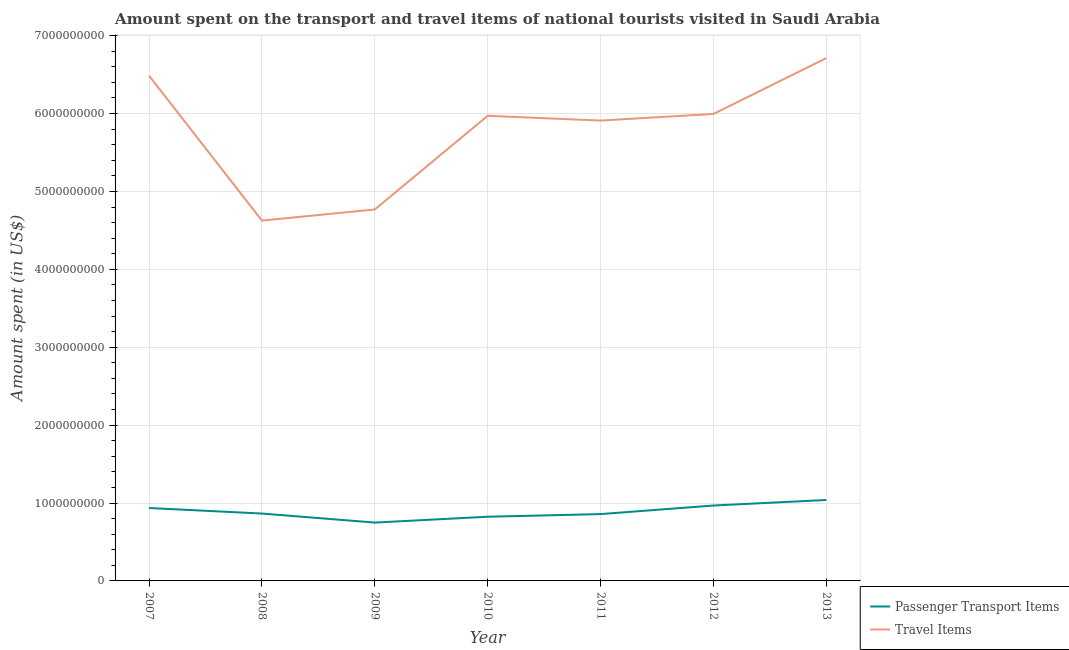How many different coloured lines are there?
Your answer should be very brief. 2. Does the line corresponding to amount spent on passenger transport items intersect with the line corresponding to amount spent in travel items?
Your response must be concise. No. Is the number of lines equal to the number of legend labels?
Your answer should be very brief. Yes. What is the amount spent in travel items in 2009?
Your answer should be very brief. 4.77e+09. Across all years, what is the maximum amount spent on passenger transport items?
Ensure brevity in your answer.  1.04e+09. Across all years, what is the minimum amount spent in travel items?
Your answer should be compact. 4.63e+09. What is the total amount spent in travel items in the graph?
Make the answer very short. 4.05e+1. What is the difference between the amount spent on passenger transport items in 2007 and that in 2010?
Your response must be concise. 1.12e+08. What is the difference between the amount spent on passenger transport items in 2013 and the amount spent in travel items in 2008?
Provide a short and direct response. -3.59e+09. What is the average amount spent on passenger transport items per year?
Offer a terse response. 8.91e+08. In the year 2008, what is the difference between the amount spent in travel items and amount spent on passenger transport items?
Offer a very short reply. 3.76e+09. In how many years, is the amount spent on passenger transport items greater than 400000000 US$?
Provide a succinct answer. 7. What is the ratio of the amount spent in travel items in 2011 to that in 2013?
Provide a succinct answer. 0.88. What is the difference between the highest and the second highest amount spent on passenger transport items?
Provide a succinct answer. 7.10e+07. What is the difference between the highest and the lowest amount spent in travel items?
Your answer should be compact. 2.09e+09. In how many years, is the amount spent on passenger transport items greater than the average amount spent on passenger transport items taken over all years?
Provide a succinct answer. 3. Is the sum of the amount spent in travel items in 2007 and 2012 greater than the maximum amount spent on passenger transport items across all years?
Keep it short and to the point. Yes. How many lines are there?
Provide a succinct answer. 2. Are the values on the major ticks of Y-axis written in scientific E-notation?
Offer a terse response. No. Does the graph contain grids?
Give a very brief answer. Yes. Where does the legend appear in the graph?
Keep it short and to the point. Bottom right. How many legend labels are there?
Your response must be concise. 2. How are the legend labels stacked?
Make the answer very short. Vertical. What is the title of the graph?
Keep it short and to the point. Amount spent on the transport and travel items of national tourists visited in Saudi Arabia. Does "Female" appear as one of the legend labels in the graph?
Provide a succinct answer. No. What is the label or title of the Y-axis?
Offer a terse response. Amount spent (in US$). What is the Amount spent (in US$) in Passenger Transport Items in 2007?
Give a very brief answer. 9.36e+08. What is the Amount spent (in US$) in Travel Items in 2007?
Ensure brevity in your answer.  6.49e+09. What is the Amount spent (in US$) of Passenger Transport Items in 2008?
Ensure brevity in your answer.  8.65e+08. What is the Amount spent (in US$) of Travel Items in 2008?
Ensure brevity in your answer.  4.63e+09. What is the Amount spent (in US$) in Passenger Transport Items in 2009?
Provide a short and direct response. 7.49e+08. What is the Amount spent (in US$) of Travel Items in 2009?
Ensure brevity in your answer.  4.77e+09. What is the Amount spent (in US$) of Passenger Transport Items in 2010?
Offer a terse response. 8.24e+08. What is the Amount spent (in US$) of Travel Items in 2010?
Keep it short and to the point. 5.97e+09. What is the Amount spent (in US$) in Passenger Transport Items in 2011?
Offer a terse response. 8.58e+08. What is the Amount spent (in US$) of Travel Items in 2011?
Keep it short and to the point. 5.91e+09. What is the Amount spent (in US$) in Passenger Transport Items in 2012?
Your answer should be very brief. 9.68e+08. What is the Amount spent (in US$) in Travel Items in 2012?
Your answer should be compact. 6.00e+09. What is the Amount spent (in US$) of Passenger Transport Items in 2013?
Your answer should be compact. 1.04e+09. What is the Amount spent (in US$) in Travel Items in 2013?
Make the answer very short. 6.71e+09. Across all years, what is the maximum Amount spent (in US$) in Passenger Transport Items?
Offer a very short reply. 1.04e+09. Across all years, what is the maximum Amount spent (in US$) of Travel Items?
Keep it short and to the point. 6.71e+09. Across all years, what is the minimum Amount spent (in US$) of Passenger Transport Items?
Your answer should be compact. 7.49e+08. Across all years, what is the minimum Amount spent (in US$) in Travel Items?
Offer a terse response. 4.63e+09. What is the total Amount spent (in US$) in Passenger Transport Items in the graph?
Offer a terse response. 6.24e+09. What is the total Amount spent (in US$) in Travel Items in the graph?
Provide a short and direct response. 4.05e+1. What is the difference between the Amount spent (in US$) of Passenger Transport Items in 2007 and that in 2008?
Your response must be concise. 7.10e+07. What is the difference between the Amount spent (in US$) of Travel Items in 2007 and that in 2008?
Your answer should be very brief. 1.86e+09. What is the difference between the Amount spent (in US$) of Passenger Transport Items in 2007 and that in 2009?
Give a very brief answer. 1.87e+08. What is the difference between the Amount spent (in US$) of Travel Items in 2007 and that in 2009?
Make the answer very short. 1.72e+09. What is the difference between the Amount spent (in US$) of Passenger Transport Items in 2007 and that in 2010?
Your answer should be very brief. 1.12e+08. What is the difference between the Amount spent (in US$) in Travel Items in 2007 and that in 2010?
Offer a very short reply. 5.15e+08. What is the difference between the Amount spent (in US$) of Passenger Transport Items in 2007 and that in 2011?
Provide a short and direct response. 7.80e+07. What is the difference between the Amount spent (in US$) in Travel Items in 2007 and that in 2011?
Offer a very short reply. 5.76e+08. What is the difference between the Amount spent (in US$) of Passenger Transport Items in 2007 and that in 2012?
Ensure brevity in your answer.  -3.20e+07. What is the difference between the Amount spent (in US$) in Travel Items in 2007 and that in 2012?
Ensure brevity in your answer.  4.91e+08. What is the difference between the Amount spent (in US$) of Passenger Transport Items in 2007 and that in 2013?
Your answer should be very brief. -1.03e+08. What is the difference between the Amount spent (in US$) in Travel Items in 2007 and that in 2013?
Your response must be concise. -2.26e+08. What is the difference between the Amount spent (in US$) in Passenger Transport Items in 2008 and that in 2009?
Ensure brevity in your answer.  1.16e+08. What is the difference between the Amount spent (in US$) in Travel Items in 2008 and that in 2009?
Make the answer very short. -1.43e+08. What is the difference between the Amount spent (in US$) in Passenger Transport Items in 2008 and that in 2010?
Make the answer very short. 4.10e+07. What is the difference between the Amount spent (in US$) in Travel Items in 2008 and that in 2010?
Your response must be concise. -1.34e+09. What is the difference between the Amount spent (in US$) of Travel Items in 2008 and that in 2011?
Provide a short and direct response. -1.28e+09. What is the difference between the Amount spent (in US$) in Passenger Transport Items in 2008 and that in 2012?
Offer a very short reply. -1.03e+08. What is the difference between the Amount spent (in US$) of Travel Items in 2008 and that in 2012?
Your answer should be compact. -1.37e+09. What is the difference between the Amount spent (in US$) in Passenger Transport Items in 2008 and that in 2013?
Offer a terse response. -1.74e+08. What is the difference between the Amount spent (in US$) in Travel Items in 2008 and that in 2013?
Give a very brief answer. -2.09e+09. What is the difference between the Amount spent (in US$) of Passenger Transport Items in 2009 and that in 2010?
Offer a terse response. -7.50e+07. What is the difference between the Amount spent (in US$) in Travel Items in 2009 and that in 2010?
Offer a terse response. -1.20e+09. What is the difference between the Amount spent (in US$) of Passenger Transport Items in 2009 and that in 2011?
Provide a succinct answer. -1.09e+08. What is the difference between the Amount spent (in US$) of Travel Items in 2009 and that in 2011?
Your answer should be compact. -1.14e+09. What is the difference between the Amount spent (in US$) in Passenger Transport Items in 2009 and that in 2012?
Make the answer very short. -2.19e+08. What is the difference between the Amount spent (in US$) in Travel Items in 2009 and that in 2012?
Give a very brief answer. -1.23e+09. What is the difference between the Amount spent (in US$) of Passenger Transport Items in 2009 and that in 2013?
Ensure brevity in your answer.  -2.90e+08. What is the difference between the Amount spent (in US$) in Travel Items in 2009 and that in 2013?
Provide a short and direct response. -1.94e+09. What is the difference between the Amount spent (in US$) in Passenger Transport Items in 2010 and that in 2011?
Offer a terse response. -3.40e+07. What is the difference between the Amount spent (in US$) in Travel Items in 2010 and that in 2011?
Make the answer very short. 6.10e+07. What is the difference between the Amount spent (in US$) in Passenger Transport Items in 2010 and that in 2012?
Offer a very short reply. -1.44e+08. What is the difference between the Amount spent (in US$) of Travel Items in 2010 and that in 2012?
Your response must be concise. -2.40e+07. What is the difference between the Amount spent (in US$) of Passenger Transport Items in 2010 and that in 2013?
Offer a terse response. -2.15e+08. What is the difference between the Amount spent (in US$) of Travel Items in 2010 and that in 2013?
Make the answer very short. -7.41e+08. What is the difference between the Amount spent (in US$) in Passenger Transport Items in 2011 and that in 2012?
Keep it short and to the point. -1.10e+08. What is the difference between the Amount spent (in US$) in Travel Items in 2011 and that in 2012?
Your answer should be compact. -8.50e+07. What is the difference between the Amount spent (in US$) in Passenger Transport Items in 2011 and that in 2013?
Provide a succinct answer. -1.81e+08. What is the difference between the Amount spent (in US$) of Travel Items in 2011 and that in 2013?
Your answer should be very brief. -8.02e+08. What is the difference between the Amount spent (in US$) of Passenger Transport Items in 2012 and that in 2013?
Your answer should be compact. -7.10e+07. What is the difference between the Amount spent (in US$) of Travel Items in 2012 and that in 2013?
Make the answer very short. -7.17e+08. What is the difference between the Amount spent (in US$) of Passenger Transport Items in 2007 and the Amount spent (in US$) of Travel Items in 2008?
Provide a succinct answer. -3.69e+09. What is the difference between the Amount spent (in US$) of Passenger Transport Items in 2007 and the Amount spent (in US$) of Travel Items in 2009?
Ensure brevity in your answer.  -3.83e+09. What is the difference between the Amount spent (in US$) of Passenger Transport Items in 2007 and the Amount spent (in US$) of Travel Items in 2010?
Your response must be concise. -5.04e+09. What is the difference between the Amount spent (in US$) of Passenger Transport Items in 2007 and the Amount spent (in US$) of Travel Items in 2011?
Provide a short and direct response. -4.97e+09. What is the difference between the Amount spent (in US$) of Passenger Transport Items in 2007 and the Amount spent (in US$) of Travel Items in 2012?
Provide a short and direct response. -5.06e+09. What is the difference between the Amount spent (in US$) in Passenger Transport Items in 2007 and the Amount spent (in US$) in Travel Items in 2013?
Make the answer very short. -5.78e+09. What is the difference between the Amount spent (in US$) in Passenger Transport Items in 2008 and the Amount spent (in US$) in Travel Items in 2009?
Make the answer very short. -3.90e+09. What is the difference between the Amount spent (in US$) in Passenger Transport Items in 2008 and the Amount spent (in US$) in Travel Items in 2010?
Keep it short and to the point. -5.11e+09. What is the difference between the Amount spent (in US$) of Passenger Transport Items in 2008 and the Amount spent (in US$) of Travel Items in 2011?
Provide a succinct answer. -5.04e+09. What is the difference between the Amount spent (in US$) of Passenger Transport Items in 2008 and the Amount spent (in US$) of Travel Items in 2012?
Your answer should be very brief. -5.13e+09. What is the difference between the Amount spent (in US$) in Passenger Transport Items in 2008 and the Amount spent (in US$) in Travel Items in 2013?
Give a very brief answer. -5.85e+09. What is the difference between the Amount spent (in US$) of Passenger Transport Items in 2009 and the Amount spent (in US$) of Travel Items in 2010?
Make the answer very short. -5.22e+09. What is the difference between the Amount spent (in US$) of Passenger Transport Items in 2009 and the Amount spent (in US$) of Travel Items in 2011?
Your response must be concise. -5.16e+09. What is the difference between the Amount spent (in US$) in Passenger Transport Items in 2009 and the Amount spent (in US$) in Travel Items in 2012?
Your answer should be compact. -5.25e+09. What is the difference between the Amount spent (in US$) of Passenger Transport Items in 2009 and the Amount spent (in US$) of Travel Items in 2013?
Make the answer very short. -5.96e+09. What is the difference between the Amount spent (in US$) in Passenger Transport Items in 2010 and the Amount spent (in US$) in Travel Items in 2011?
Offer a very short reply. -5.09e+09. What is the difference between the Amount spent (in US$) in Passenger Transport Items in 2010 and the Amount spent (in US$) in Travel Items in 2012?
Provide a succinct answer. -5.17e+09. What is the difference between the Amount spent (in US$) of Passenger Transport Items in 2010 and the Amount spent (in US$) of Travel Items in 2013?
Offer a very short reply. -5.89e+09. What is the difference between the Amount spent (in US$) of Passenger Transport Items in 2011 and the Amount spent (in US$) of Travel Items in 2012?
Provide a short and direct response. -5.14e+09. What is the difference between the Amount spent (in US$) of Passenger Transport Items in 2011 and the Amount spent (in US$) of Travel Items in 2013?
Provide a succinct answer. -5.85e+09. What is the difference between the Amount spent (in US$) of Passenger Transport Items in 2012 and the Amount spent (in US$) of Travel Items in 2013?
Give a very brief answer. -5.74e+09. What is the average Amount spent (in US$) of Passenger Transport Items per year?
Offer a terse response. 8.91e+08. What is the average Amount spent (in US$) in Travel Items per year?
Provide a succinct answer. 5.78e+09. In the year 2007, what is the difference between the Amount spent (in US$) in Passenger Transport Items and Amount spent (in US$) in Travel Items?
Give a very brief answer. -5.55e+09. In the year 2008, what is the difference between the Amount spent (in US$) in Passenger Transport Items and Amount spent (in US$) in Travel Items?
Offer a very short reply. -3.76e+09. In the year 2009, what is the difference between the Amount spent (in US$) of Passenger Transport Items and Amount spent (in US$) of Travel Items?
Offer a terse response. -4.02e+09. In the year 2010, what is the difference between the Amount spent (in US$) of Passenger Transport Items and Amount spent (in US$) of Travel Items?
Keep it short and to the point. -5.15e+09. In the year 2011, what is the difference between the Amount spent (in US$) of Passenger Transport Items and Amount spent (in US$) of Travel Items?
Your answer should be compact. -5.05e+09. In the year 2012, what is the difference between the Amount spent (in US$) in Passenger Transport Items and Amount spent (in US$) in Travel Items?
Keep it short and to the point. -5.03e+09. In the year 2013, what is the difference between the Amount spent (in US$) of Passenger Transport Items and Amount spent (in US$) of Travel Items?
Offer a very short reply. -5.67e+09. What is the ratio of the Amount spent (in US$) of Passenger Transport Items in 2007 to that in 2008?
Your response must be concise. 1.08. What is the ratio of the Amount spent (in US$) in Travel Items in 2007 to that in 2008?
Make the answer very short. 1.4. What is the ratio of the Amount spent (in US$) in Passenger Transport Items in 2007 to that in 2009?
Give a very brief answer. 1.25. What is the ratio of the Amount spent (in US$) of Travel Items in 2007 to that in 2009?
Provide a short and direct response. 1.36. What is the ratio of the Amount spent (in US$) in Passenger Transport Items in 2007 to that in 2010?
Give a very brief answer. 1.14. What is the ratio of the Amount spent (in US$) in Travel Items in 2007 to that in 2010?
Your response must be concise. 1.09. What is the ratio of the Amount spent (in US$) of Passenger Transport Items in 2007 to that in 2011?
Your response must be concise. 1.09. What is the ratio of the Amount spent (in US$) in Travel Items in 2007 to that in 2011?
Your response must be concise. 1.1. What is the ratio of the Amount spent (in US$) of Passenger Transport Items in 2007 to that in 2012?
Make the answer very short. 0.97. What is the ratio of the Amount spent (in US$) in Travel Items in 2007 to that in 2012?
Keep it short and to the point. 1.08. What is the ratio of the Amount spent (in US$) in Passenger Transport Items in 2007 to that in 2013?
Provide a succinct answer. 0.9. What is the ratio of the Amount spent (in US$) in Travel Items in 2007 to that in 2013?
Offer a terse response. 0.97. What is the ratio of the Amount spent (in US$) in Passenger Transport Items in 2008 to that in 2009?
Ensure brevity in your answer.  1.15. What is the ratio of the Amount spent (in US$) in Passenger Transport Items in 2008 to that in 2010?
Offer a very short reply. 1.05. What is the ratio of the Amount spent (in US$) of Travel Items in 2008 to that in 2010?
Offer a terse response. 0.77. What is the ratio of the Amount spent (in US$) in Passenger Transport Items in 2008 to that in 2011?
Ensure brevity in your answer.  1.01. What is the ratio of the Amount spent (in US$) of Travel Items in 2008 to that in 2011?
Your answer should be very brief. 0.78. What is the ratio of the Amount spent (in US$) in Passenger Transport Items in 2008 to that in 2012?
Offer a very short reply. 0.89. What is the ratio of the Amount spent (in US$) of Travel Items in 2008 to that in 2012?
Ensure brevity in your answer.  0.77. What is the ratio of the Amount spent (in US$) in Passenger Transport Items in 2008 to that in 2013?
Provide a succinct answer. 0.83. What is the ratio of the Amount spent (in US$) of Travel Items in 2008 to that in 2013?
Your answer should be very brief. 0.69. What is the ratio of the Amount spent (in US$) in Passenger Transport Items in 2009 to that in 2010?
Your answer should be very brief. 0.91. What is the ratio of the Amount spent (in US$) of Travel Items in 2009 to that in 2010?
Offer a very short reply. 0.8. What is the ratio of the Amount spent (in US$) of Passenger Transport Items in 2009 to that in 2011?
Provide a succinct answer. 0.87. What is the ratio of the Amount spent (in US$) of Travel Items in 2009 to that in 2011?
Provide a succinct answer. 0.81. What is the ratio of the Amount spent (in US$) in Passenger Transport Items in 2009 to that in 2012?
Your answer should be very brief. 0.77. What is the ratio of the Amount spent (in US$) in Travel Items in 2009 to that in 2012?
Provide a short and direct response. 0.8. What is the ratio of the Amount spent (in US$) of Passenger Transport Items in 2009 to that in 2013?
Ensure brevity in your answer.  0.72. What is the ratio of the Amount spent (in US$) of Travel Items in 2009 to that in 2013?
Offer a terse response. 0.71. What is the ratio of the Amount spent (in US$) of Passenger Transport Items in 2010 to that in 2011?
Offer a very short reply. 0.96. What is the ratio of the Amount spent (in US$) of Travel Items in 2010 to that in 2011?
Offer a very short reply. 1.01. What is the ratio of the Amount spent (in US$) in Passenger Transport Items in 2010 to that in 2012?
Your response must be concise. 0.85. What is the ratio of the Amount spent (in US$) of Passenger Transport Items in 2010 to that in 2013?
Ensure brevity in your answer.  0.79. What is the ratio of the Amount spent (in US$) of Travel Items in 2010 to that in 2013?
Keep it short and to the point. 0.89. What is the ratio of the Amount spent (in US$) of Passenger Transport Items in 2011 to that in 2012?
Ensure brevity in your answer.  0.89. What is the ratio of the Amount spent (in US$) of Travel Items in 2011 to that in 2012?
Your response must be concise. 0.99. What is the ratio of the Amount spent (in US$) in Passenger Transport Items in 2011 to that in 2013?
Offer a very short reply. 0.83. What is the ratio of the Amount spent (in US$) of Travel Items in 2011 to that in 2013?
Provide a short and direct response. 0.88. What is the ratio of the Amount spent (in US$) in Passenger Transport Items in 2012 to that in 2013?
Your answer should be very brief. 0.93. What is the ratio of the Amount spent (in US$) of Travel Items in 2012 to that in 2013?
Your answer should be very brief. 0.89. What is the difference between the highest and the second highest Amount spent (in US$) in Passenger Transport Items?
Your answer should be very brief. 7.10e+07. What is the difference between the highest and the second highest Amount spent (in US$) in Travel Items?
Keep it short and to the point. 2.26e+08. What is the difference between the highest and the lowest Amount spent (in US$) of Passenger Transport Items?
Ensure brevity in your answer.  2.90e+08. What is the difference between the highest and the lowest Amount spent (in US$) in Travel Items?
Your answer should be very brief. 2.09e+09. 